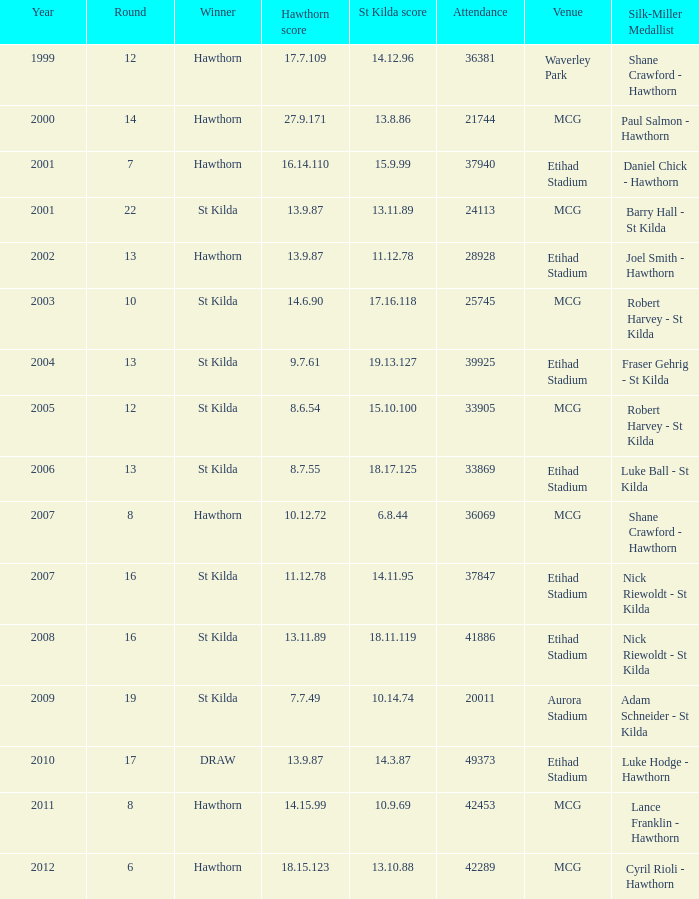What the listed in round when the hawthorn score is 17.7.109? 12.0. 